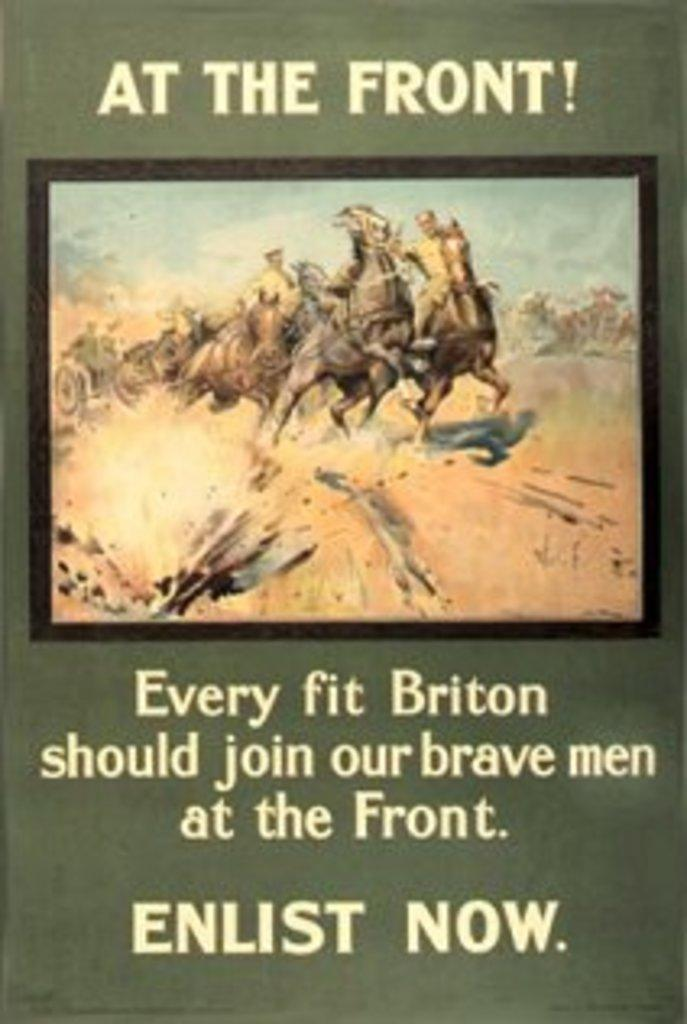<image>
Describe the image concisely. An ad calling for every firt briton to enlist now. 